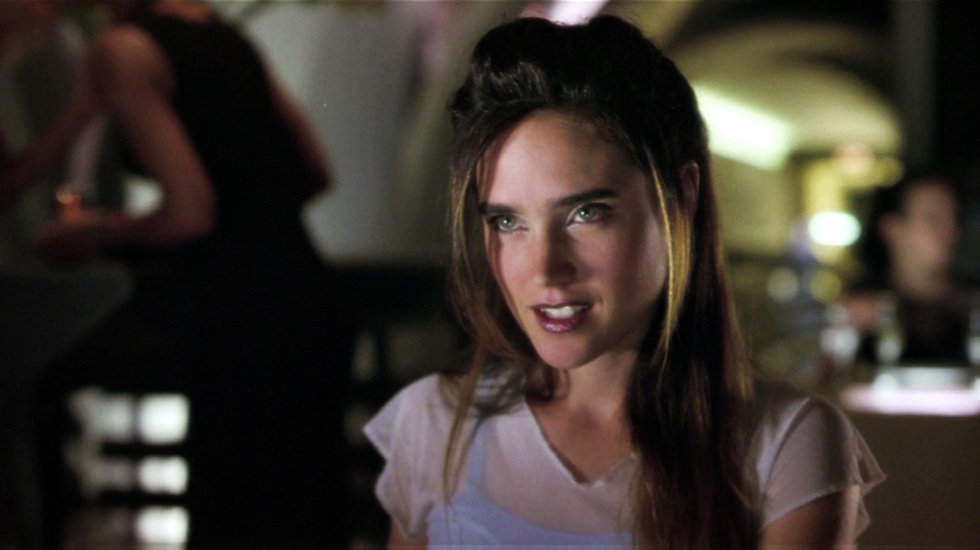What can you tell me about the woman's style in this image? The woman in the image has a minimalist, yet chic style. She is wearing a simple white top that has a timeless appeal. Her hairstyle is effortless, with locks gently pulled back to reveal her face, which suggests a casual elegance. Her look is understated but refined, fitting for a variety of social settings. 